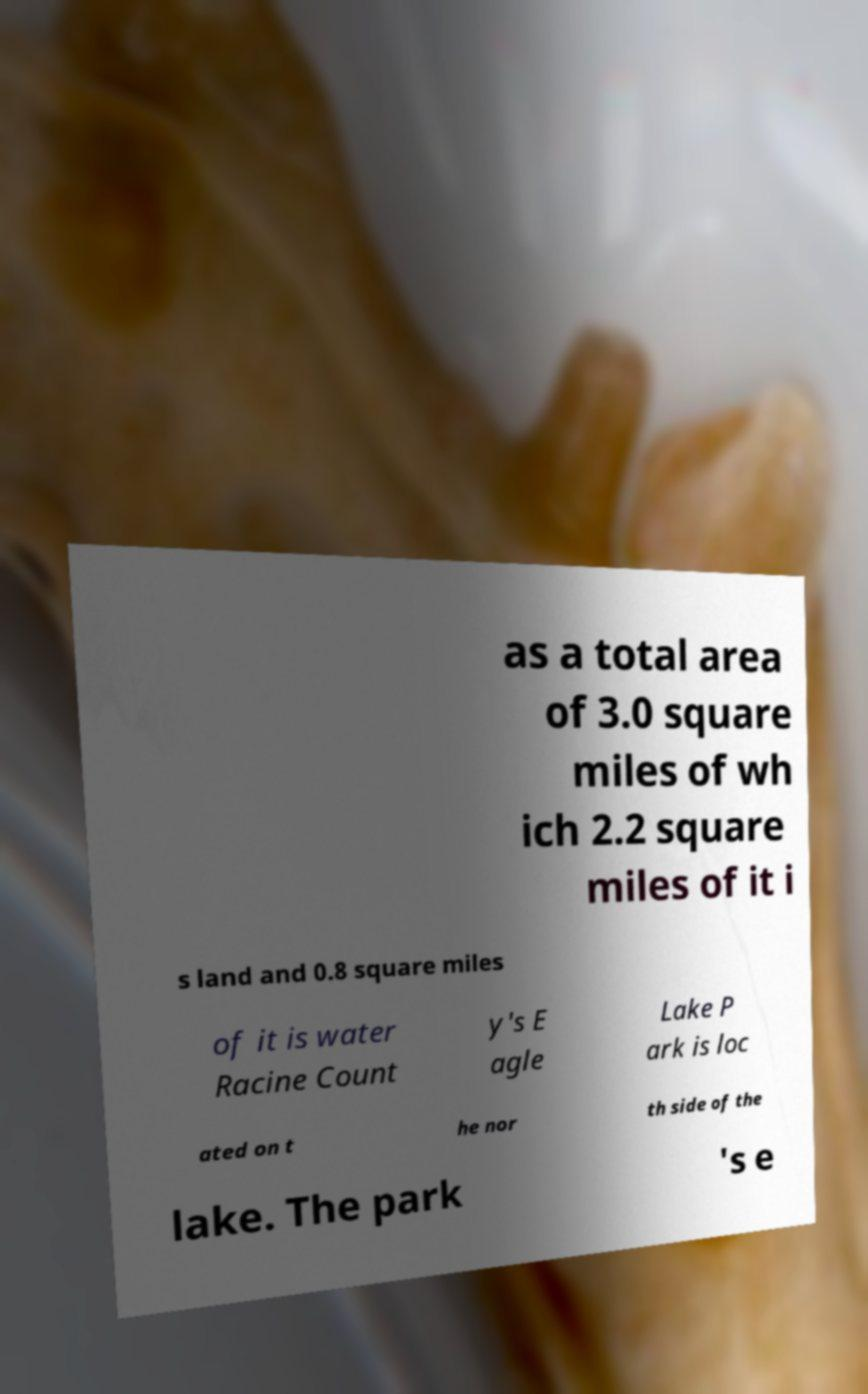What messages or text are displayed in this image? I need them in a readable, typed format. as a total area of 3.0 square miles of wh ich 2.2 square miles of it i s land and 0.8 square miles of it is water Racine Count y's E agle Lake P ark is loc ated on t he nor th side of the lake. The park 's e 